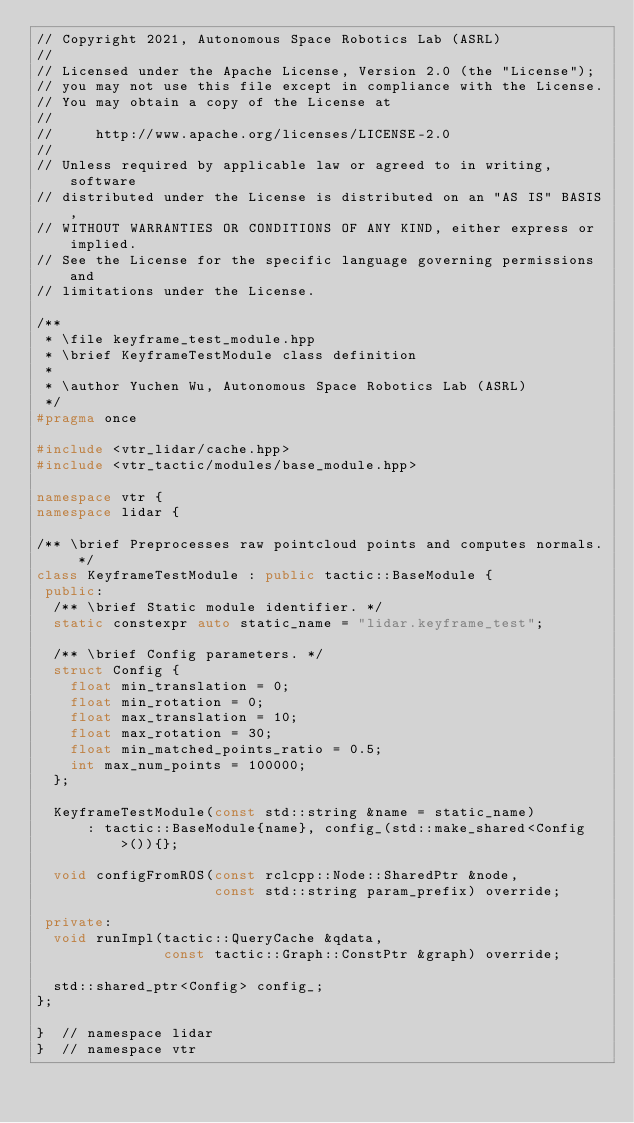Convert code to text. <code><loc_0><loc_0><loc_500><loc_500><_C++_>// Copyright 2021, Autonomous Space Robotics Lab (ASRL)
//
// Licensed under the Apache License, Version 2.0 (the "License");
// you may not use this file except in compliance with the License.
// You may obtain a copy of the License at
//
//     http://www.apache.org/licenses/LICENSE-2.0
//
// Unless required by applicable law or agreed to in writing, software
// distributed under the License is distributed on an "AS IS" BASIS,
// WITHOUT WARRANTIES OR CONDITIONS OF ANY KIND, either express or implied.
// See the License for the specific language governing permissions and
// limitations under the License.

/**
 * \file keyframe_test_module.hpp
 * \brief KeyframeTestModule class definition
 *
 * \author Yuchen Wu, Autonomous Space Robotics Lab (ASRL)
 */
#pragma once

#include <vtr_lidar/cache.hpp>
#include <vtr_tactic/modules/base_module.hpp>

namespace vtr {
namespace lidar {

/** \brief Preprocesses raw pointcloud points and computes normals. */
class KeyframeTestModule : public tactic::BaseModule {
 public:
  /** \brief Static module identifier. */
  static constexpr auto static_name = "lidar.keyframe_test";

  /** \brief Config parameters. */
  struct Config {
    float min_translation = 0;
    float min_rotation = 0;
    float max_translation = 10;
    float max_rotation = 30;
    float min_matched_points_ratio = 0.5;
    int max_num_points = 100000;
  };

  KeyframeTestModule(const std::string &name = static_name)
      : tactic::BaseModule{name}, config_(std::make_shared<Config>()){};

  void configFromROS(const rclcpp::Node::SharedPtr &node,
                     const std::string param_prefix) override;

 private:
  void runImpl(tactic::QueryCache &qdata,
               const tactic::Graph::ConstPtr &graph) override;

  std::shared_ptr<Config> config_;
};

}  // namespace lidar
}  // namespace vtr</code> 